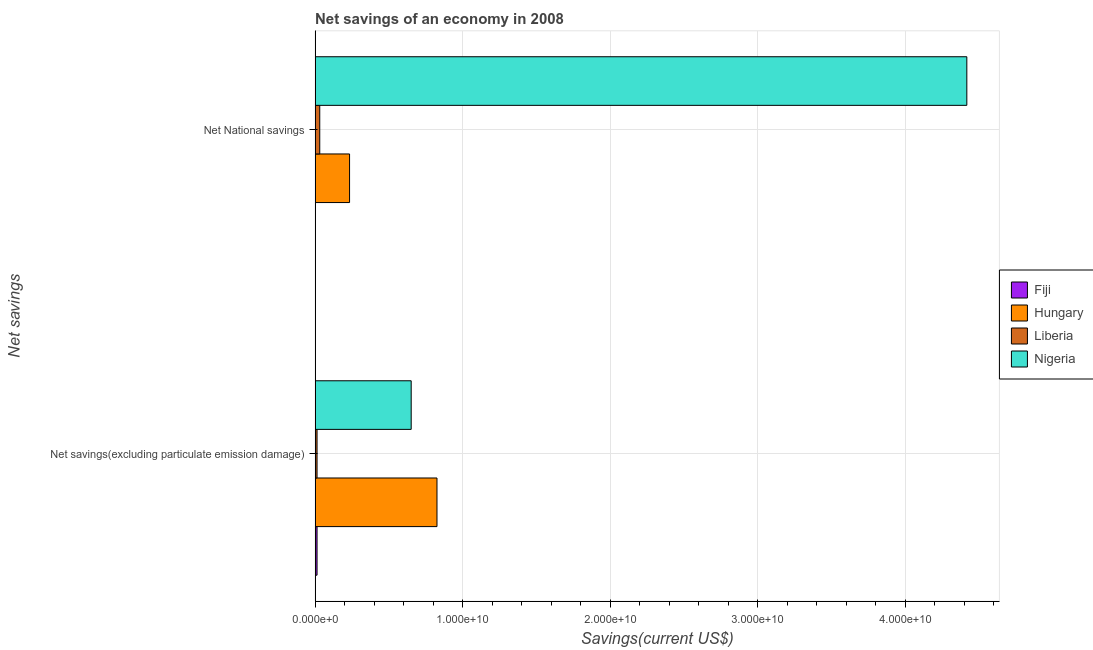How many different coloured bars are there?
Provide a short and direct response. 4. How many groups of bars are there?
Offer a very short reply. 2. Are the number of bars per tick equal to the number of legend labels?
Make the answer very short. No. How many bars are there on the 2nd tick from the top?
Give a very brief answer. 4. How many bars are there on the 2nd tick from the bottom?
Ensure brevity in your answer.  3. What is the label of the 1st group of bars from the top?
Your response must be concise. Net National savings. What is the net savings(excluding particulate emission damage) in Fiji?
Offer a terse response. 1.31e+08. Across all countries, what is the maximum net savings(excluding particulate emission damage)?
Keep it short and to the point. 8.26e+09. Across all countries, what is the minimum net national savings?
Give a very brief answer. 0. In which country was the net national savings maximum?
Offer a terse response. Nigeria. What is the total net savings(excluding particulate emission damage) in the graph?
Your response must be concise. 1.50e+1. What is the difference between the net savings(excluding particulate emission damage) in Nigeria and that in Hungary?
Provide a succinct answer. -1.75e+09. What is the difference between the net savings(excluding particulate emission damage) in Nigeria and the net national savings in Liberia?
Ensure brevity in your answer.  6.20e+09. What is the average net national savings per country?
Ensure brevity in your answer.  1.17e+1. What is the difference between the net savings(excluding particulate emission damage) and net national savings in Liberia?
Give a very brief answer. -1.83e+08. In how many countries, is the net savings(excluding particulate emission damage) greater than 38000000000 US$?
Offer a very short reply. 0. What is the ratio of the net savings(excluding particulate emission damage) in Liberia to that in Fiji?
Provide a succinct answer. 1. In how many countries, is the net savings(excluding particulate emission damage) greater than the average net savings(excluding particulate emission damage) taken over all countries?
Give a very brief answer. 2. How many bars are there?
Give a very brief answer. 7. Are all the bars in the graph horizontal?
Offer a terse response. Yes. Are the values on the major ticks of X-axis written in scientific E-notation?
Make the answer very short. Yes. Does the graph contain any zero values?
Offer a very short reply. Yes. How many legend labels are there?
Your answer should be compact. 4. How are the legend labels stacked?
Your answer should be very brief. Vertical. What is the title of the graph?
Keep it short and to the point. Net savings of an economy in 2008. What is the label or title of the X-axis?
Offer a terse response. Savings(current US$). What is the label or title of the Y-axis?
Give a very brief answer. Net savings. What is the Savings(current US$) of Fiji in Net savings(excluding particulate emission damage)?
Offer a very short reply. 1.31e+08. What is the Savings(current US$) of Hungary in Net savings(excluding particulate emission damage)?
Provide a succinct answer. 8.26e+09. What is the Savings(current US$) of Liberia in Net savings(excluding particulate emission damage)?
Give a very brief answer. 1.32e+08. What is the Savings(current US$) of Nigeria in Net savings(excluding particulate emission damage)?
Give a very brief answer. 6.51e+09. What is the Savings(current US$) of Hungary in Net National savings?
Your response must be concise. 2.34e+09. What is the Savings(current US$) in Liberia in Net National savings?
Make the answer very short. 3.15e+08. What is the Savings(current US$) in Nigeria in Net National savings?
Ensure brevity in your answer.  4.42e+1. Across all Net savings, what is the maximum Savings(current US$) of Fiji?
Your response must be concise. 1.31e+08. Across all Net savings, what is the maximum Savings(current US$) in Hungary?
Your answer should be compact. 8.26e+09. Across all Net savings, what is the maximum Savings(current US$) of Liberia?
Ensure brevity in your answer.  3.15e+08. Across all Net savings, what is the maximum Savings(current US$) in Nigeria?
Your response must be concise. 4.42e+1. Across all Net savings, what is the minimum Savings(current US$) in Fiji?
Offer a terse response. 0. Across all Net savings, what is the minimum Savings(current US$) of Hungary?
Make the answer very short. 2.34e+09. Across all Net savings, what is the minimum Savings(current US$) of Liberia?
Your response must be concise. 1.32e+08. Across all Net savings, what is the minimum Savings(current US$) in Nigeria?
Keep it short and to the point. 6.51e+09. What is the total Savings(current US$) in Fiji in the graph?
Your answer should be compact. 1.31e+08. What is the total Savings(current US$) of Hungary in the graph?
Your answer should be compact. 1.06e+1. What is the total Savings(current US$) of Liberia in the graph?
Keep it short and to the point. 4.47e+08. What is the total Savings(current US$) of Nigeria in the graph?
Provide a succinct answer. 5.07e+1. What is the difference between the Savings(current US$) in Hungary in Net savings(excluding particulate emission damage) and that in Net National savings?
Make the answer very short. 5.93e+09. What is the difference between the Savings(current US$) of Liberia in Net savings(excluding particulate emission damage) and that in Net National savings?
Provide a short and direct response. -1.83e+08. What is the difference between the Savings(current US$) in Nigeria in Net savings(excluding particulate emission damage) and that in Net National savings?
Ensure brevity in your answer.  -3.77e+1. What is the difference between the Savings(current US$) in Fiji in Net savings(excluding particulate emission damage) and the Savings(current US$) in Hungary in Net National savings?
Your answer should be very brief. -2.20e+09. What is the difference between the Savings(current US$) of Fiji in Net savings(excluding particulate emission damage) and the Savings(current US$) of Liberia in Net National savings?
Provide a short and direct response. -1.84e+08. What is the difference between the Savings(current US$) in Fiji in Net savings(excluding particulate emission damage) and the Savings(current US$) in Nigeria in Net National savings?
Offer a terse response. -4.41e+1. What is the difference between the Savings(current US$) of Hungary in Net savings(excluding particulate emission damage) and the Savings(current US$) of Liberia in Net National savings?
Ensure brevity in your answer.  7.95e+09. What is the difference between the Savings(current US$) of Hungary in Net savings(excluding particulate emission damage) and the Savings(current US$) of Nigeria in Net National savings?
Ensure brevity in your answer.  -3.59e+1. What is the difference between the Savings(current US$) in Liberia in Net savings(excluding particulate emission damage) and the Savings(current US$) in Nigeria in Net National savings?
Your answer should be compact. -4.41e+1. What is the average Savings(current US$) of Fiji per Net savings?
Your response must be concise. 6.57e+07. What is the average Savings(current US$) of Hungary per Net savings?
Make the answer very short. 5.30e+09. What is the average Savings(current US$) of Liberia per Net savings?
Keep it short and to the point. 2.23e+08. What is the average Savings(current US$) in Nigeria per Net savings?
Keep it short and to the point. 2.54e+1. What is the difference between the Savings(current US$) in Fiji and Savings(current US$) in Hungary in Net savings(excluding particulate emission damage)?
Keep it short and to the point. -8.13e+09. What is the difference between the Savings(current US$) of Fiji and Savings(current US$) of Liberia in Net savings(excluding particulate emission damage)?
Give a very brief answer. -5.72e+05. What is the difference between the Savings(current US$) of Fiji and Savings(current US$) of Nigeria in Net savings(excluding particulate emission damage)?
Your answer should be compact. -6.38e+09. What is the difference between the Savings(current US$) of Hungary and Savings(current US$) of Liberia in Net savings(excluding particulate emission damage)?
Offer a very short reply. 8.13e+09. What is the difference between the Savings(current US$) of Hungary and Savings(current US$) of Nigeria in Net savings(excluding particulate emission damage)?
Make the answer very short. 1.75e+09. What is the difference between the Savings(current US$) in Liberia and Savings(current US$) in Nigeria in Net savings(excluding particulate emission damage)?
Make the answer very short. -6.38e+09. What is the difference between the Savings(current US$) of Hungary and Savings(current US$) of Liberia in Net National savings?
Your response must be concise. 2.02e+09. What is the difference between the Savings(current US$) of Hungary and Savings(current US$) of Nigeria in Net National savings?
Provide a succinct answer. -4.18e+1. What is the difference between the Savings(current US$) in Liberia and Savings(current US$) in Nigeria in Net National savings?
Keep it short and to the point. -4.39e+1. What is the ratio of the Savings(current US$) in Hungary in Net savings(excluding particulate emission damage) to that in Net National savings?
Your answer should be compact. 3.54. What is the ratio of the Savings(current US$) in Liberia in Net savings(excluding particulate emission damage) to that in Net National savings?
Your answer should be compact. 0.42. What is the ratio of the Savings(current US$) in Nigeria in Net savings(excluding particulate emission damage) to that in Net National savings?
Offer a terse response. 0.15. What is the difference between the highest and the second highest Savings(current US$) in Hungary?
Provide a short and direct response. 5.93e+09. What is the difference between the highest and the second highest Savings(current US$) of Liberia?
Your response must be concise. 1.83e+08. What is the difference between the highest and the second highest Savings(current US$) in Nigeria?
Provide a succinct answer. 3.77e+1. What is the difference between the highest and the lowest Savings(current US$) of Fiji?
Provide a short and direct response. 1.31e+08. What is the difference between the highest and the lowest Savings(current US$) in Hungary?
Provide a succinct answer. 5.93e+09. What is the difference between the highest and the lowest Savings(current US$) in Liberia?
Make the answer very short. 1.83e+08. What is the difference between the highest and the lowest Savings(current US$) in Nigeria?
Offer a very short reply. 3.77e+1. 